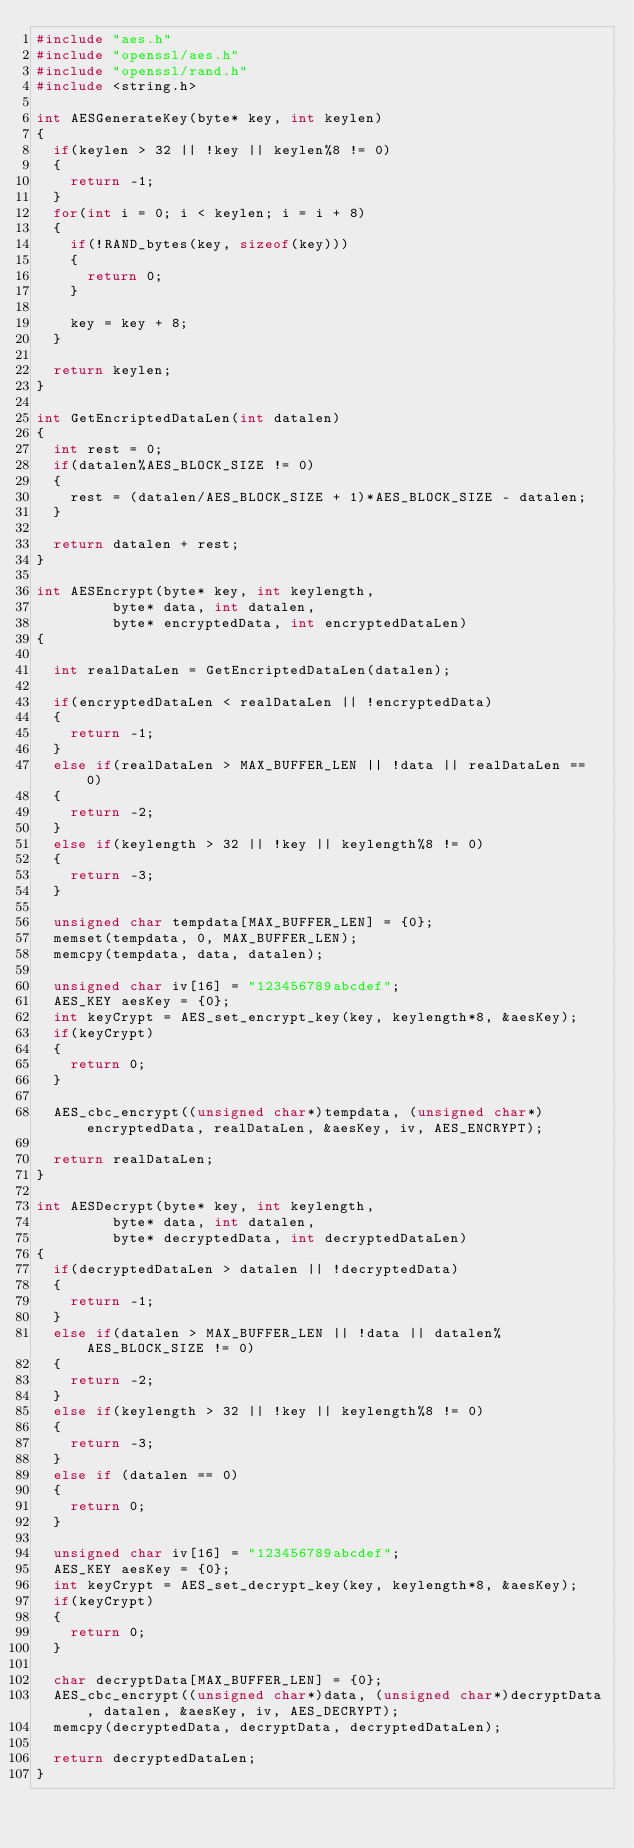Convert code to text. <code><loc_0><loc_0><loc_500><loc_500><_C++_>#include "aes.h"
#include "openssl/aes.h"
#include "openssl/rand.h"
#include <string.h>

int AESGenerateKey(byte* key, int keylen)
{
	if(keylen > 32 || !key || keylen%8 != 0)
	{
		return -1;
	}
	for(int i = 0; i < keylen; i = i + 8)
	{
		if(!RAND_bytes(key, sizeof(key)))
		{
			return 0;
		}

		key = key + 8;
	}

	return keylen;
}

int GetEncriptedDataLen(int datalen)
{
	int rest = 0;
	if(datalen%AES_BLOCK_SIZE != 0)
	{
		rest = (datalen/AES_BLOCK_SIZE + 1)*AES_BLOCK_SIZE - datalen;
	}

	return datalen + rest;
}

int AESEncrypt(byte* key, int keylength,
			   byte* data, int datalen,
			   byte* encryptedData, int encryptedDataLen)
{
	
	int realDataLen = GetEncriptedDataLen(datalen);

	if(encryptedDataLen < realDataLen || !encryptedData)
	{
		return -1;
	}
	else if(realDataLen > MAX_BUFFER_LEN || !data || realDataLen == 0)
	{
		return -2;
	}
	else if(keylength > 32 || !key || keylength%8 != 0)
	{
		return -3;
	}

	unsigned char tempdata[MAX_BUFFER_LEN] = {0};
	memset(tempdata, 0, MAX_BUFFER_LEN);
	memcpy(tempdata, data, datalen);

	unsigned char iv[16] = "123456789abcdef";
	AES_KEY aesKey = {0};
	int keyCrypt = AES_set_encrypt_key(key, keylength*8, &aesKey);
	if(keyCrypt)
	{
		return 0;
	}
	
	AES_cbc_encrypt((unsigned char*)tempdata, (unsigned char*)encryptedData, realDataLen, &aesKey, iv, AES_ENCRYPT);

	return realDataLen;
}

int AESDecrypt(byte* key, int keylength,
			   byte* data, int datalen,
			   byte* decryptedData, int decryptedDataLen)
{
	if(decryptedDataLen > datalen || !decryptedData)
	{
		return -1;
	}
	else if(datalen > MAX_BUFFER_LEN || !data || datalen%AES_BLOCK_SIZE != 0)
	{
		return -2;
	}
	else if(keylength > 32 || !key || keylength%8 != 0)
	{
		return -3;
	}
	else if (datalen == 0)
	{
		return 0;
	}

	unsigned char iv[16] = "123456789abcdef";
	AES_KEY aesKey = {0};
	int keyCrypt = AES_set_decrypt_key(key, keylength*8, &aesKey);
	if(keyCrypt)
	{
		return 0;
	}

	char decryptData[MAX_BUFFER_LEN] = {0};
	AES_cbc_encrypt((unsigned char*)data, (unsigned char*)decryptData, datalen, &aesKey, iv, AES_DECRYPT);
	memcpy(decryptedData, decryptData, decryptedDataLen);

	return decryptedDataLen;
}</code> 